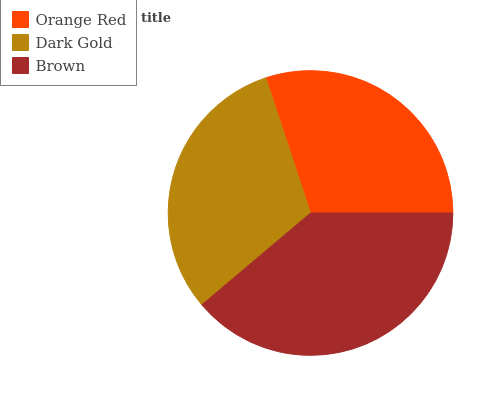Is Orange Red the minimum?
Answer yes or no. Yes. Is Brown the maximum?
Answer yes or no. Yes. Is Dark Gold the minimum?
Answer yes or no. No. Is Dark Gold the maximum?
Answer yes or no. No. Is Dark Gold greater than Orange Red?
Answer yes or no. Yes. Is Orange Red less than Dark Gold?
Answer yes or no. Yes. Is Orange Red greater than Dark Gold?
Answer yes or no. No. Is Dark Gold less than Orange Red?
Answer yes or no. No. Is Dark Gold the high median?
Answer yes or no. Yes. Is Dark Gold the low median?
Answer yes or no. Yes. Is Brown the high median?
Answer yes or no. No. Is Brown the low median?
Answer yes or no. No. 